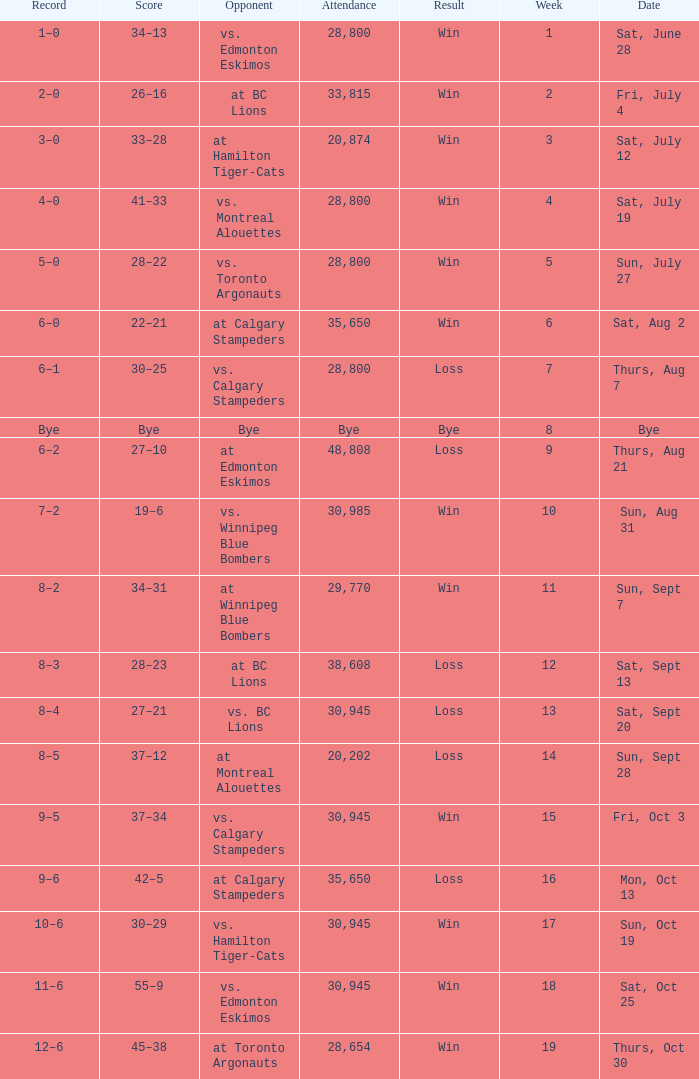What was the date of the game with an attendance of 20,874 fans? Sat, July 12. 